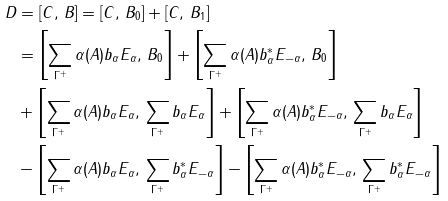<formula> <loc_0><loc_0><loc_500><loc_500>D & = [ C , \, B ] = [ C , \, B _ { 0 } ] + [ C , \, B _ { 1 } ] \\ & = \left [ \sum _ { \Gamma ^ { + } } \alpha ( A ) b _ { \alpha } E _ { \alpha } , \, B _ { 0 } \right ] + \left [ \sum _ { \Gamma ^ { + } } \alpha ( A ) b ^ { \ast } _ { \alpha } E _ { - \alpha } , \, B _ { 0 } \right ] \\ & + \left [ \sum _ { \Gamma ^ { + } } \alpha ( A ) b _ { \alpha } E _ { \alpha } , \, \sum _ { \Gamma ^ { + } } b _ { \alpha } E _ { \alpha } \right ] + \left [ \sum _ { \Gamma ^ { + } } \alpha ( A ) b ^ { \ast } _ { \alpha } E _ { - \alpha } , \, \sum _ { \Gamma ^ { + } } b _ { \alpha } E _ { \alpha } \right ] \\ & - \left [ \sum _ { \Gamma ^ { + } } \alpha ( A ) b _ { \alpha } E _ { \alpha } , \, \sum _ { \Gamma ^ { + } } b ^ { \ast } _ { \alpha } E _ { - \alpha } \right ] - \left [ \sum _ { \Gamma ^ { + } } \alpha ( A ) b ^ { \ast } _ { \alpha } E _ { - \alpha } , \, \sum _ { \Gamma ^ { + } } b ^ { \ast } _ { \alpha } E _ { - \alpha } \right ]</formula> 